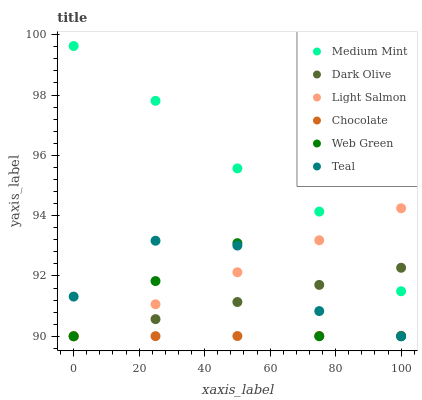Does Chocolate have the minimum area under the curve?
Answer yes or no. Yes. Does Medium Mint have the maximum area under the curve?
Answer yes or no. Yes. Does Light Salmon have the minimum area under the curve?
Answer yes or no. No. Does Light Salmon have the maximum area under the curve?
Answer yes or no. No. Is Dark Olive the smoothest?
Answer yes or no. Yes. Is Web Green the roughest?
Answer yes or no. Yes. Is Light Salmon the smoothest?
Answer yes or no. No. Is Light Salmon the roughest?
Answer yes or no. No. Does Light Salmon have the lowest value?
Answer yes or no. Yes. Does Medium Mint have the highest value?
Answer yes or no. Yes. Does Light Salmon have the highest value?
Answer yes or no. No. Is Teal less than Medium Mint?
Answer yes or no. Yes. Is Medium Mint greater than Teal?
Answer yes or no. Yes. Does Medium Mint intersect Dark Olive?
Answer yes or no. Yes. Is Medium Mint less than Dark Olive?
Answer yes or no. No. Is Medium Mint greater than Dark Olive?
Answer yes or no. No. Does Teal intersect Medium Mint?
Answer yes or no. No. 